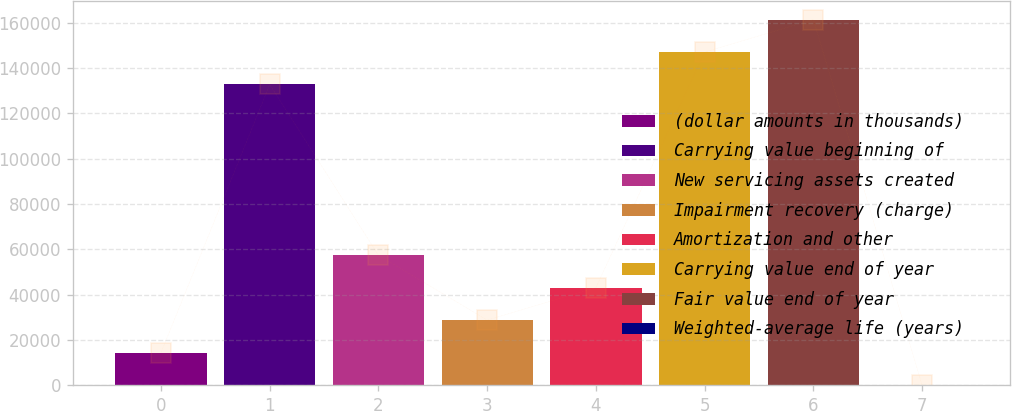Convert chart to OTSL. <chart><loc_0><loc_0><loc_500><loc_500><bar_chart><fcel>(dollar amounts in thousands)<fcel>Carrying value beginning of<fcel>New servicing assets created<fcel>Impairment recovery (charge)<fcel>Amortization and other<fcel>Carrying value end of year<fcel>Fair value end of year<fcel>Weighted-average life (years)<nl><fcel>14348.8<fcel>132812<fcel>57377.5<fcel>28691.7<fcel>43034.6<fcel>147155<fcel>161498<fcel>5.9<nl></chart> 